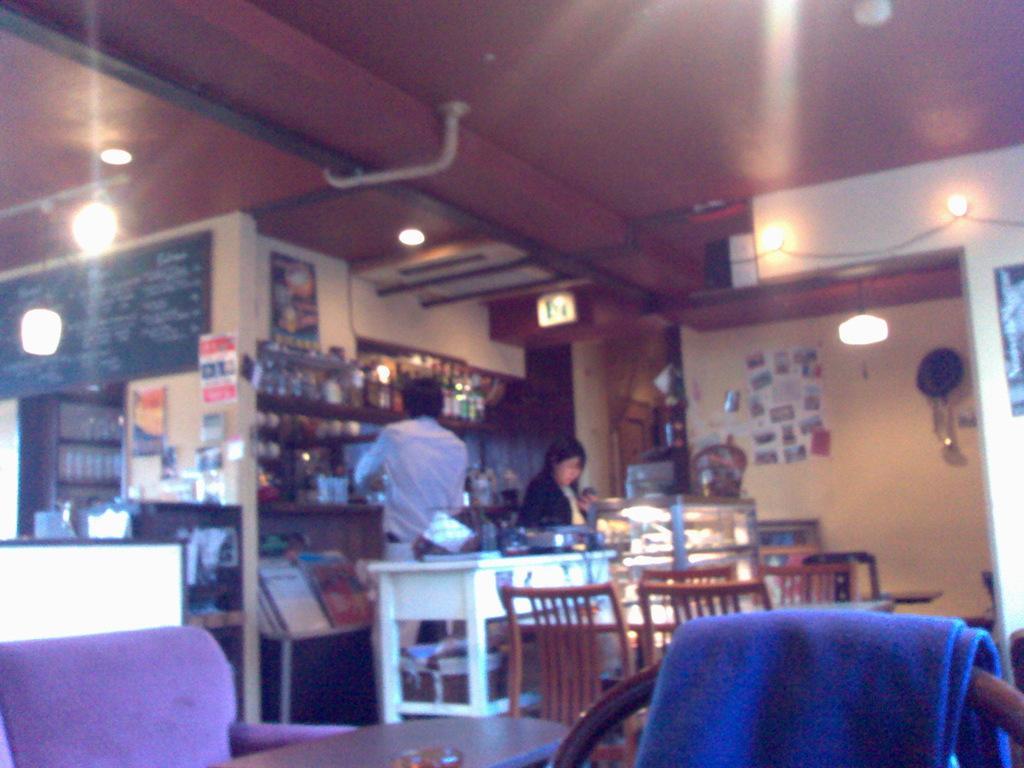Can you describe this image briefly? In this image, we can see some chairs and we can see some tables, there are two persons standing, we can see some lights and there are some food items in the containers. 